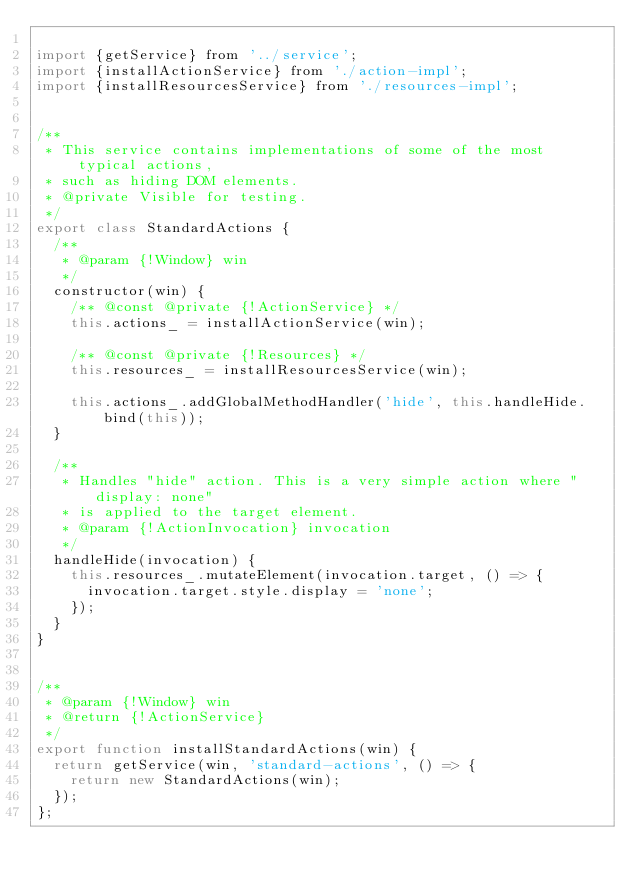Convert code to text. <code><loc_0><loc_0><loc_500><loc_500><_JavaScript_>
import {getService} from '../service';
import {installActionService} from './action-impl';
import {installResourcesService} from './resources-impl';


/**
 * This service contains implementations of some of the most typical actions,
 * such as hiding DOM elements.
 * @private Visible for testing.
 */
export class StandardActions {
  /**
   * @param {!Window} win
   */
  constructor(win) {
    /** @const @private {!ActionService} */
    this.actions_ = installActionService(win);

    /** @const @private {!Resources} */
    this.resources_ = installResourcesService(win);

    this.actions_.addGlobalMethodHandler('hide', this.handleHide.bind(this));
  }

  /**
   * Handles "hide" action. This is a very simple action where "display: none"
   * is applied to the target element.
   * @param {!ActionInvocation} invocation
   */
  handleHide(invocation) {
    this.resources_.mutateElement(invocation.target, () => {
      invocation.target.style.display = 'none';
    });
  }
}


/**
 * @param {!Window} win
 * @return {!ActionService}
 */
export function installStandardActions(win) {
  return getService(win, 'standard-actions', () => {
    return new StandardActions(win);
  });
};
</code> 